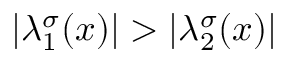Convert formula to latex. <formula><loc_0><loc_0><loc_500><loc_500>| \lambda _ { 1 } ^ { \sigma } ( x ) | > | \lambda _ { 2 } ^ { \sigma } ( x ) |</formula> 